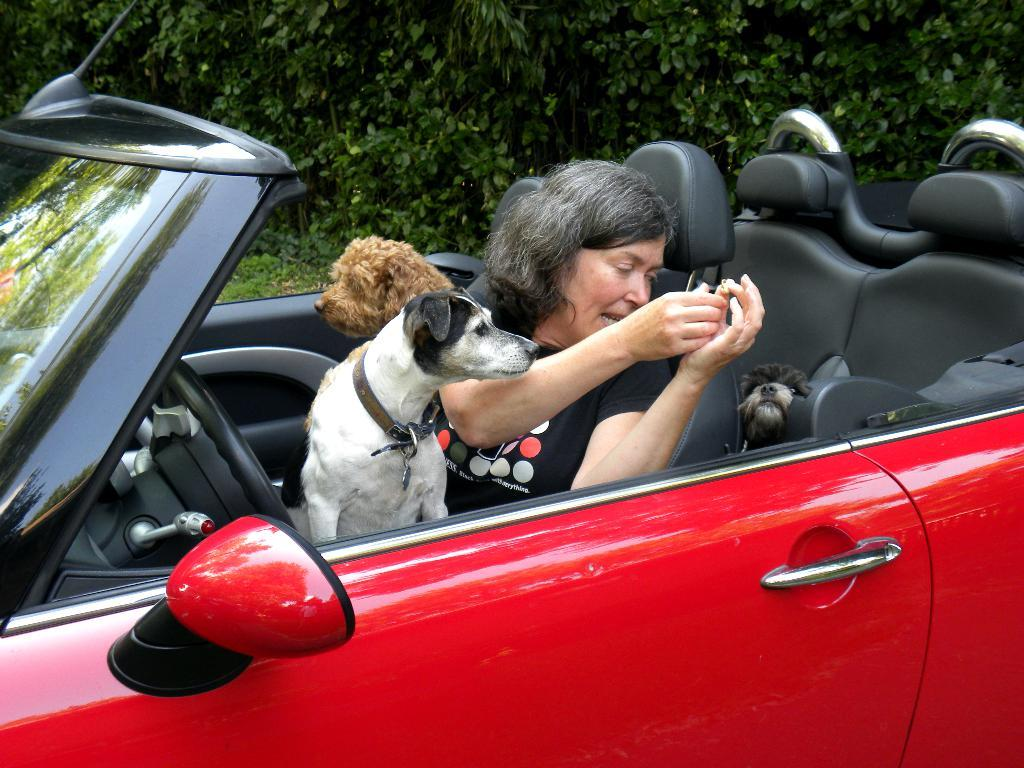What is the main subject of the picture? The main subject of the picture is a car. Who or what is inside the car? A woman is sitting in the car, and there are three dogs in the car. What is the color of the car? The car is red. What can be seen in the background of the picture? There are trees in the background of the picture. How many times does the water drain from the tub in the image? There is no tub or water present in the image; it features a car with a woman and three dogs inside. 